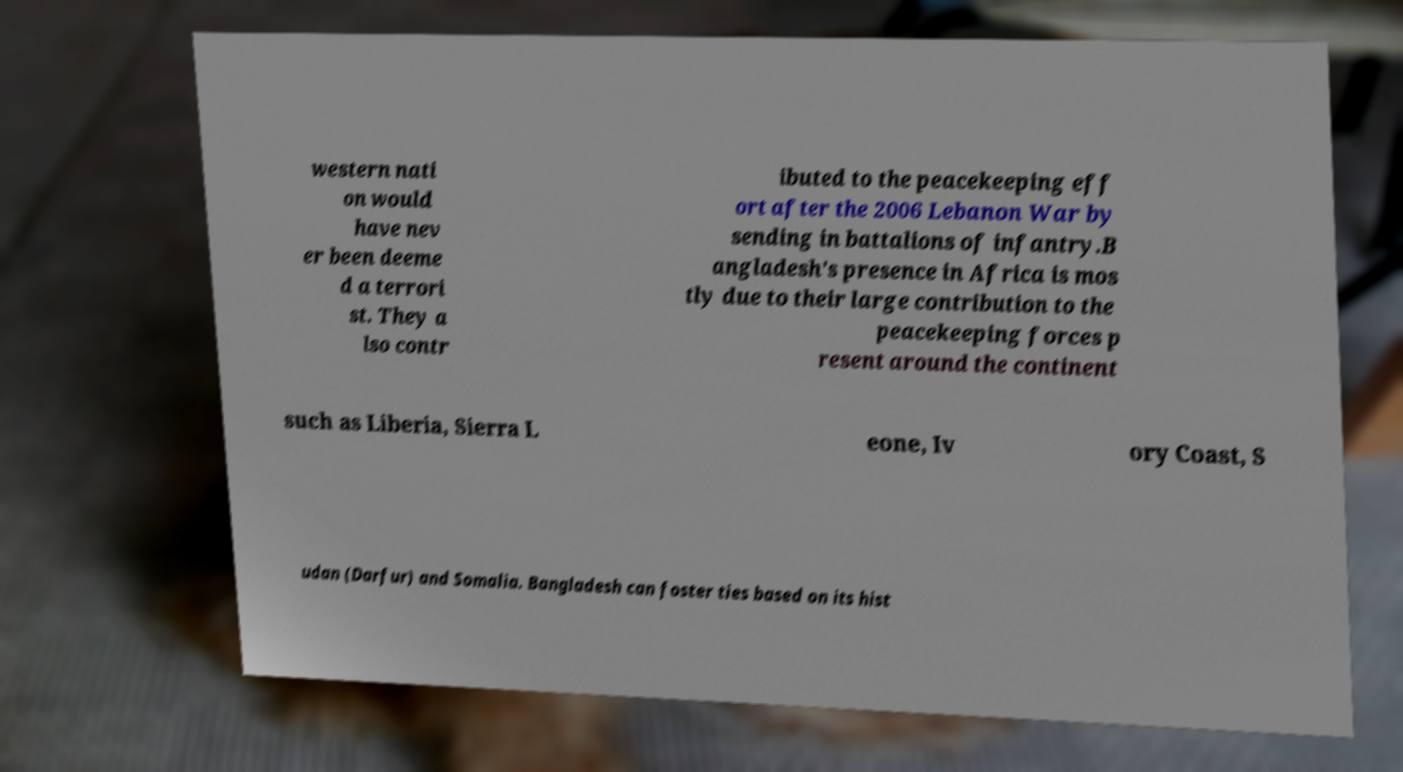Could you extract and type out the text from this image? western nati on would have nev er been deeme d a terrori st. They a lso contr ibuted to the peacekeeping eff ort after the 2006 Lebanon War by sending in battalions of infantry.B angladesh's presence in Africa is mos tly due to their large contribution to the peacekeeping forces p resent around the continent such as Liberia, Sierra L eone, Iv ory Coast, S udan (Darfur) and Somalia. Bangladesh can foster ties based on its hist 